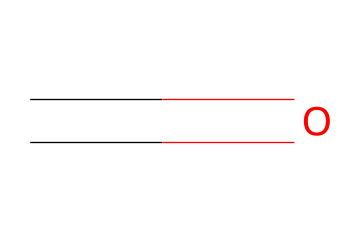What is the molecular formula of this chemical? The structure C=O indicates there is one carbon (C) atom and one oxygen (O) atom. Therefore, the molecular formula is derived by combining these counts.
Answer: CH2O How many total atoms are present in this molecule? The molecule consists of 1 carbon atom and 1 oxygen atom (counted from C=O) and 2 hydrogen atoms (inferred from the common valency of carbon in organic compounds). So, 1 (C) + 1 (O) + 2 (H) = 4 total atoms.
Answer: 4 What type of bond is present in this molecule? The structure shows a double bond between carbon and oxygen, indicated by the '=' sign in the SMILES representation. Most commonly, this is a carbonyl group which is characteristic of aldehydes and ketones.
Answer: double bond Is this chemical classified as an aldehyde or a ketone? The presence of the carbonyl group (C=O) attached to a carbon with two hydrogen atoms signifies that it is an aldehyde (specifically, formaldehyde).
Answer: aldehyde What is a common use of this chemical in industry? Formaldehyde is widely used as a preservative and in the manufacture of resins and building materials, including some types of office furniture.
Answer: preservative What health hazard is associated with this chemical? Formaldehyde is known to be a toxic substance and can cause respiratory issues, allergic reactions, and it is classified as a potential human carcinogen.
Answer: toxic and carcinogenic What physical state is this chemical at room temperature? Formaldehyde is typically found as a gas at room temperature, although it can be dissolved in water to form formalin, which is a liquid.
Answer: gas 